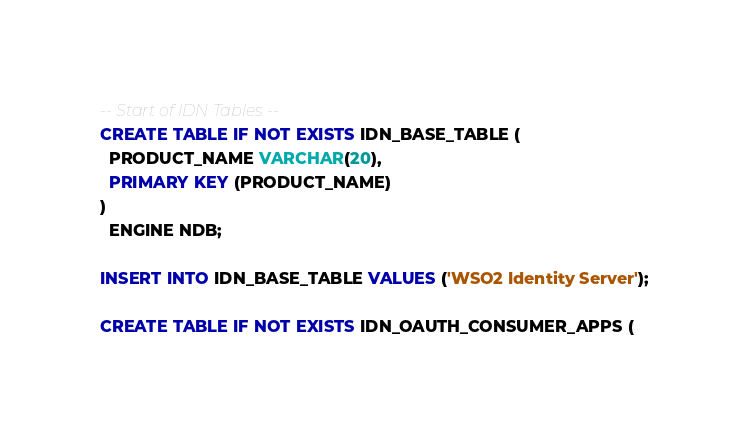Convert code to text. <code><loc_0><loc_0><loc_500><loc_500><_SQL_>-- Start of IDN Tables --
CREATE TABLE IF NOT EXISTS IDN_BASE_TABLE (
  PRODUCT_NAME VARCHAR(20),
  PRIMARY KEY (PRODUCT_NAME)
)
  ENGINE NDB;

INSERT INTO IDN_BASE_TABLE VALUES ('WSO2 Identity Server');

CREATE TABLE IF NOT EXISTS IDN_OAUTH_CONSUMER_APPS (</code> 